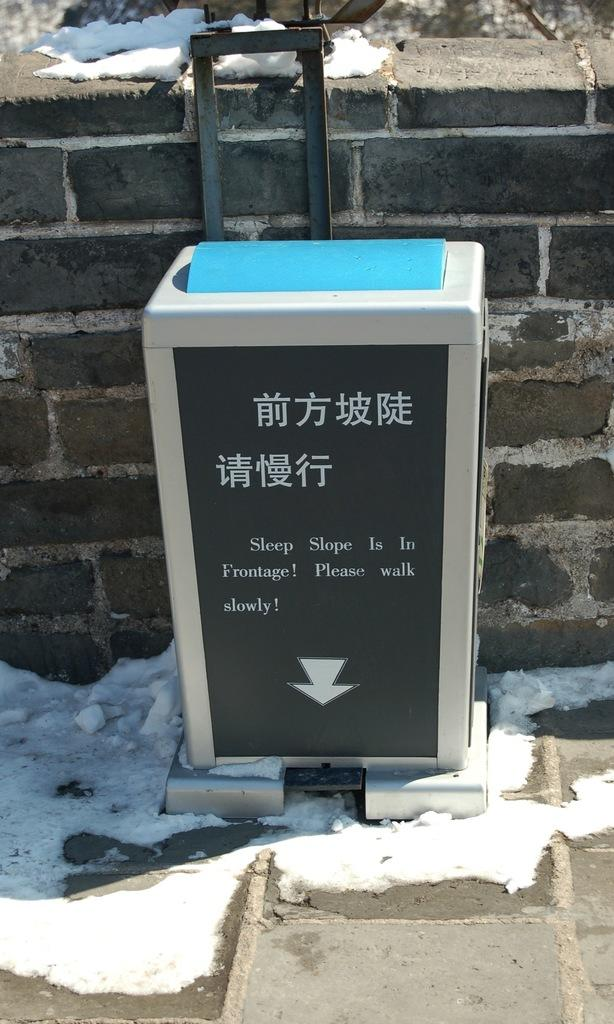<image>
Create a compact narrative representing the image presented. Square bin that has a sign which says "Sleep slope is in Frontage". 